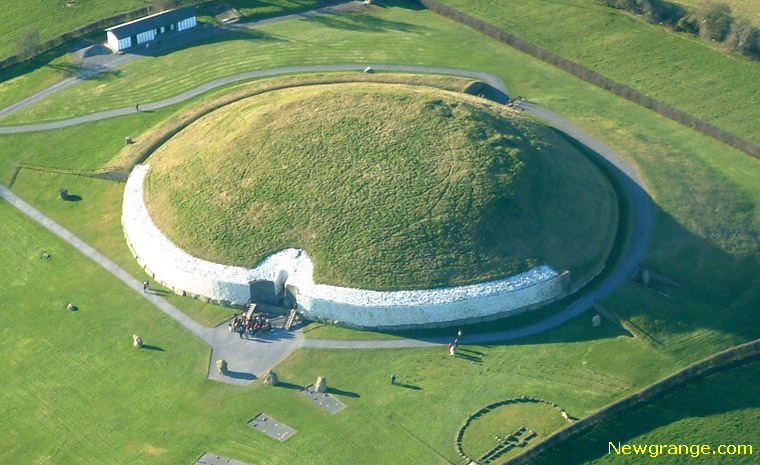Imagine the stories that the interior of Newgrange could tell. What might they be? Entering the ancient passage of Newgrange, one might be transported through thousands of years of history. The walls could whisper tales of ancient rites and ceremonies conducted by Neolithic people. Maybe it was a site where tribes gathered to honor their dead, believing the inner chamber connected to the afterlife. The carvings and megalithic art inside could narrate myths and legends of gods and spirits worshipped by the builders. The roof, designed to allow the winter solstice sunlight to pierce the darkness, could symbolize renewal and the triumph of light over darkness, offering a profound connection between the celestial events and earthly rituals. 